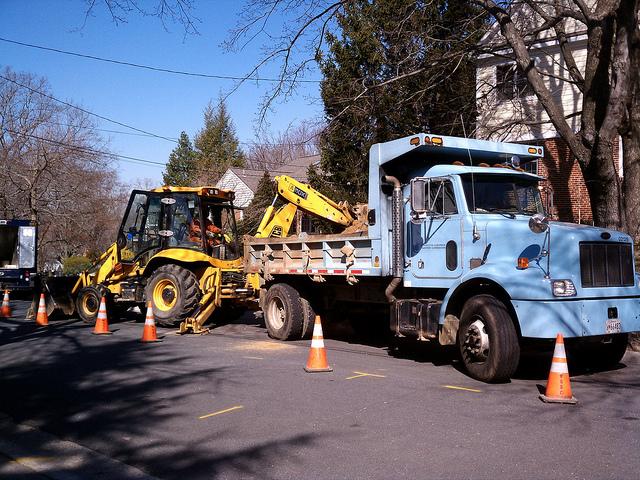Is the ground wet?
Concise answer only. No. Where is the truck sitting?
Concise answer only. Side of road. What color are the cones?
Give a very brief answer. Orange and white. Where is the truck located?
Concise answer only. Street. 